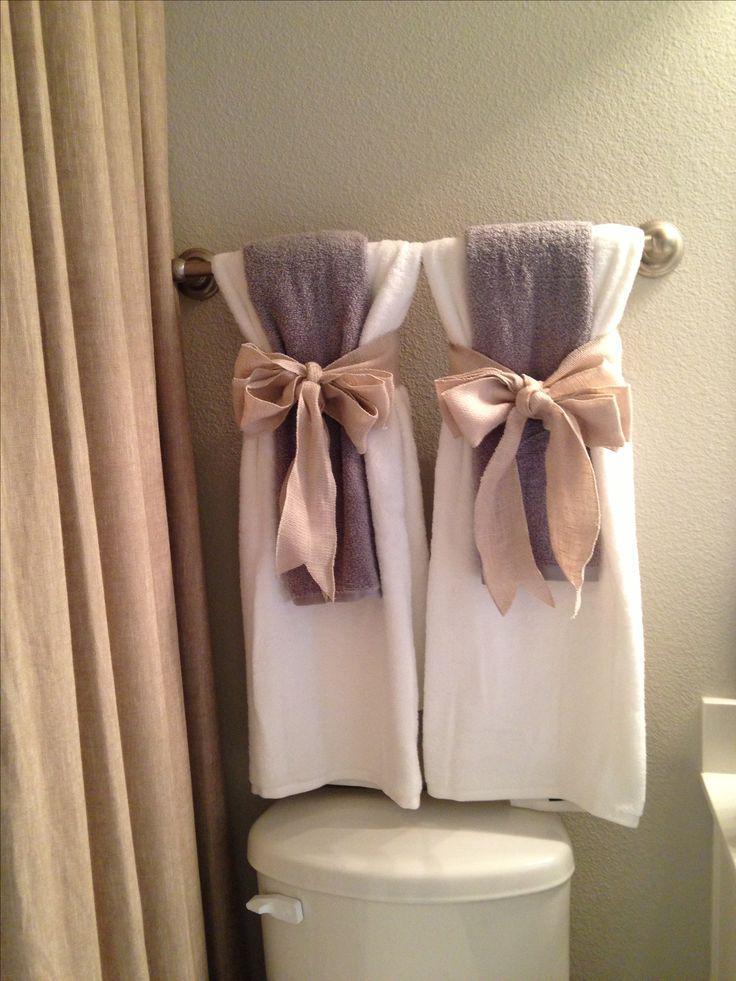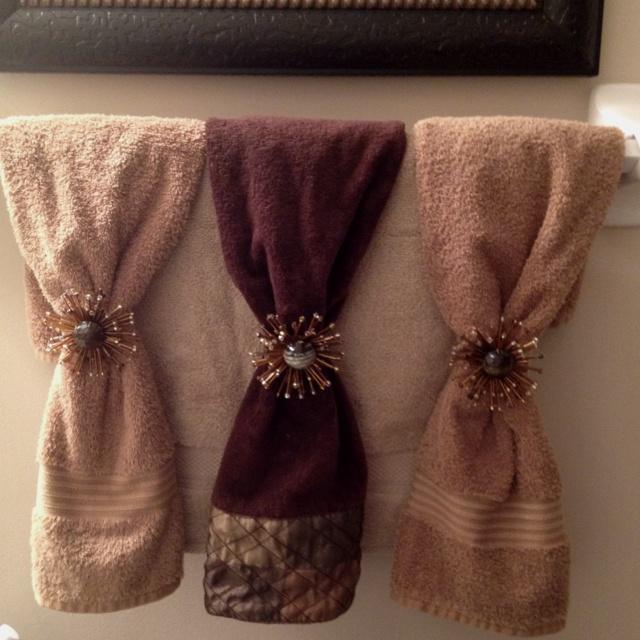The first image is the image on the left, the second image is the image on the right. Examine the images to the left and right. Is the description "The left and right image contains the same number of rows of tie towels." accurate? Answer yes or no. No. 